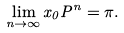Convert formula to latex. <formula><loc_0><loc_0><loc_500><loc_500>\lim _ { n \rightarrow \infty } x _ { 0 } P ^ { n } = \pi .</formula> 